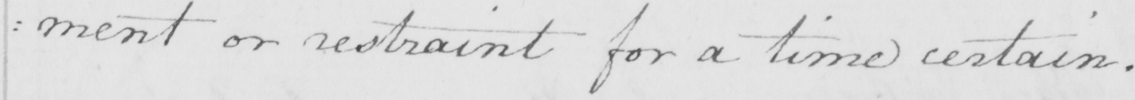What is written in this line of handwriting? : ment or restraint for a time certain . 